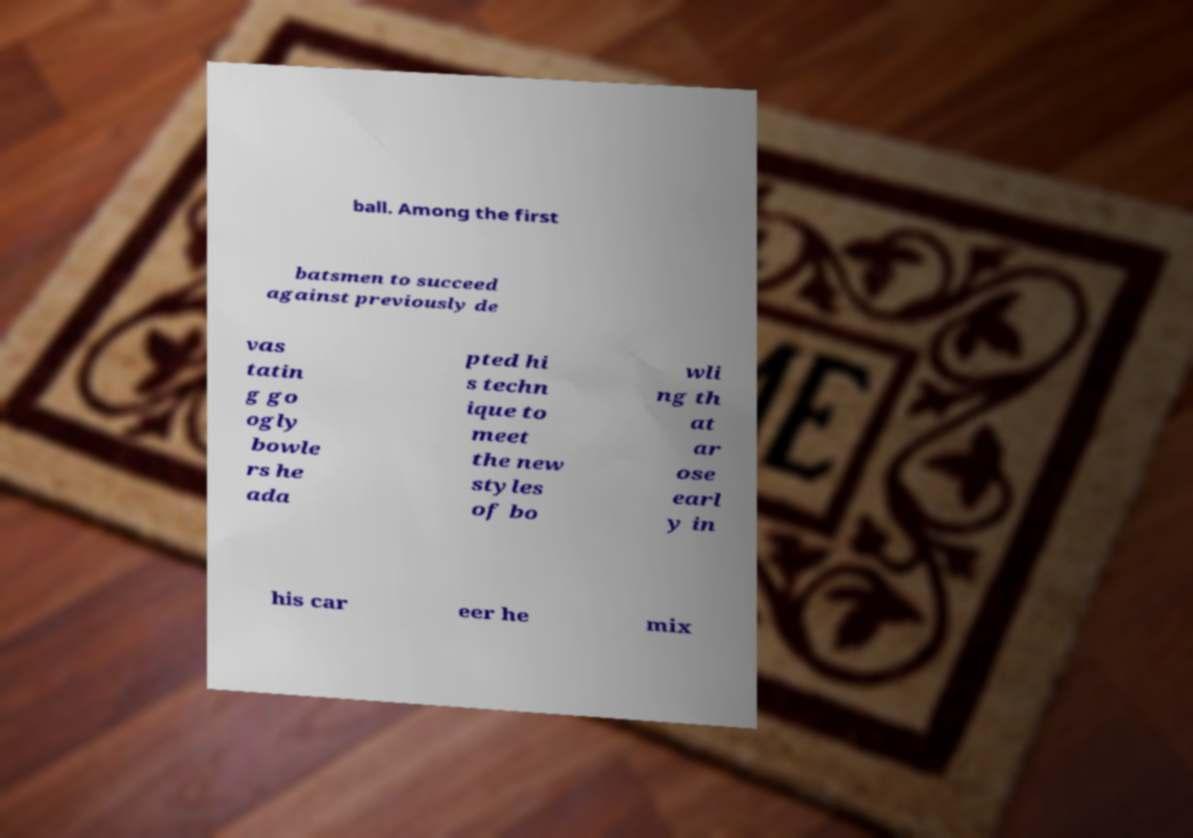Can you accurately transcribe the text from the provided image for me? ball. Among the first batsmen to succeed against previously de vas tatin g go ogly bowle rs he ada pted hi s techn ique to meet the new styles of bo wli ng th at ar ose earl y in his car eer he mix 